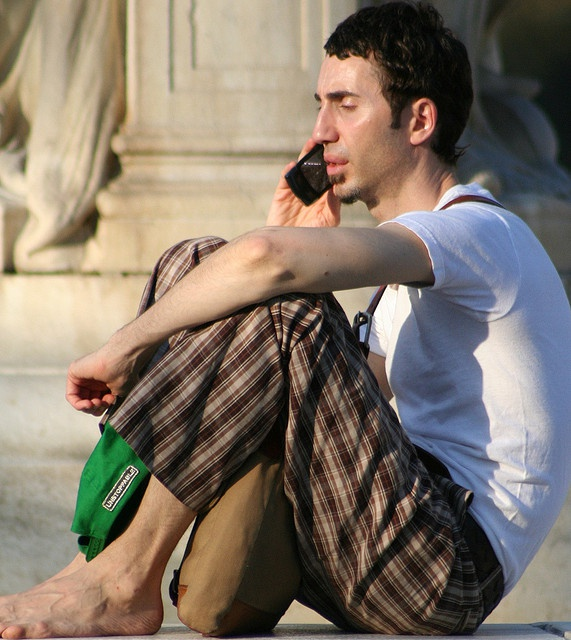Describe the objects in this image and their specific colors. I can see people in gray, black, and tan tones, handbag in gray, black, tan, and maroon tones, and cell phone in gray, black, maroon, and tan tones in this image. 